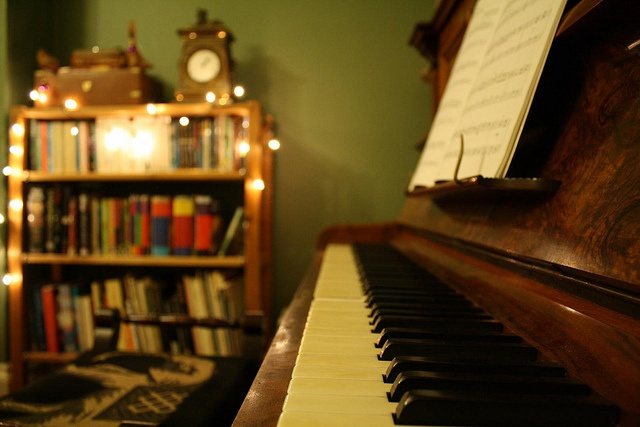Describe the objects in this image and their specific colors. I can see book in olive, black, and maroon tones, book in olive and tan tones, book in olive, black, and maroon tones, clock in olive, maroon, and khaki tones, and book in olive, tan, and maroon tones in this image. 